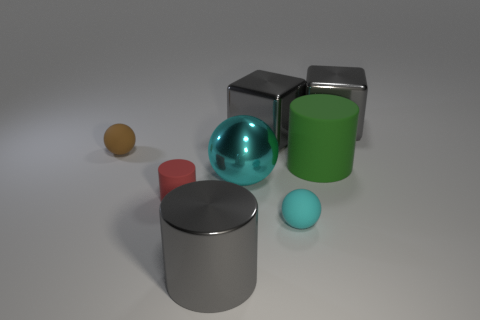Subtract all gray cylinders. How many cyan spheres are left? 2 Subtract 1 cylinders. How many cylinders are left? 2 Subtract all rubber balls. How many balls are left? 1 Subtract all cylinders. How many objects are left? 5 Add 1 cyan shiny blocks. How many objects exist? 9 Add 4 red rubber things. How many red rubber things exist? 5 Subtract 1 green cylinders. How many objects are left? 7 Subtract all green things. Subtract all cyan metallic spheres. How many objects are left? 6 Add 4 cubes. How many cubes are left? 6 